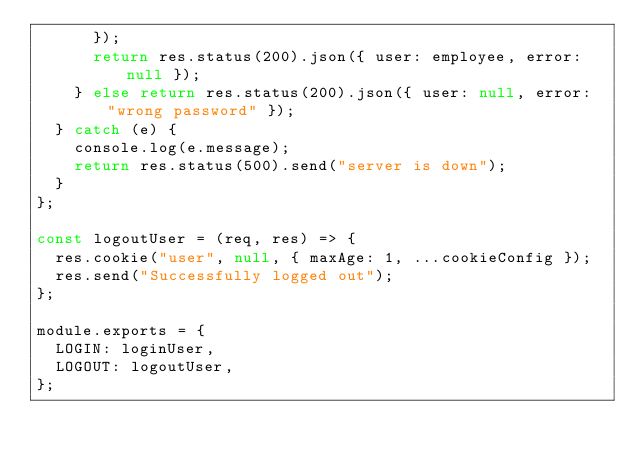<code> <loc_0><loc_0><loc_500><loc_500><_JavaScript_>      });
      return res.status(200).json({ user: employee, error: null });
    } else return res.status(200).json({ user: null, error: "wrong password" });
  } catch (e) {
    console.log(e.message);
    return res.status(500).send("server is down");
  }
};

const logoutUser = (req, res) => {
  res.cookie("user", null, { maxAge: 1, ...cookieConfig });
  res.send("Successfully logged out");
};

module.exports = {
  LOGIN: loginUser,
  LOGOUT: logoutUser,
};
</code> 